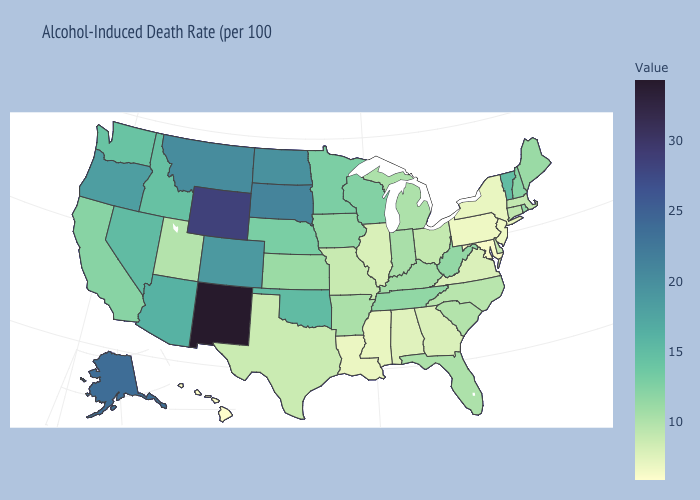Does Missouri have a higher value than Hawaii?
Concise answer only. Yes. Among the states that border Wyoming , does South Dakota have the highest value?
Keep it brief. Yes. Among the states that border New Hampshire , which have the lowest value?
Quick response, please. Massachusetts. Is the legend a continuous bar?
Quick response, please. Yes. Which states have the highest value in the USA?
Write a very short answer. New Mexico. Does Rhode Island have the highest value in the Northeast?
Give a very brief answer. No. Is the legend a continuous bar?
Short answer required. Yes. 